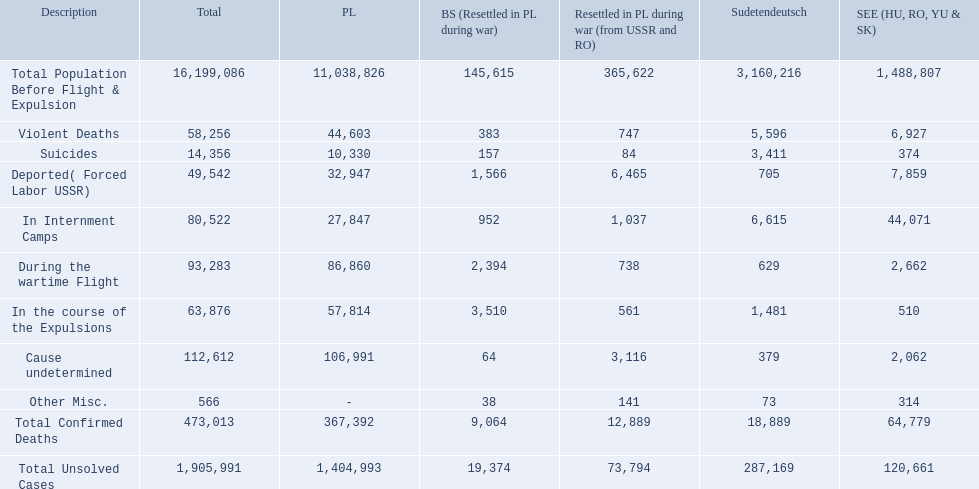What were all of the types of deaths? Violent Deaths, Suicides, Deported( Forced Labor USSR), In Internment Camps, During the wartime Flight, In the course of the Expulsions, Cause undetermined, Other Misc. And their totals in the baltic states? 383, 157, 1,566, 952, 2,394, 3,510, 64, 38. Were more deaths in the baltic states caused by undetermined causes or misc.? Cause undetermined. 